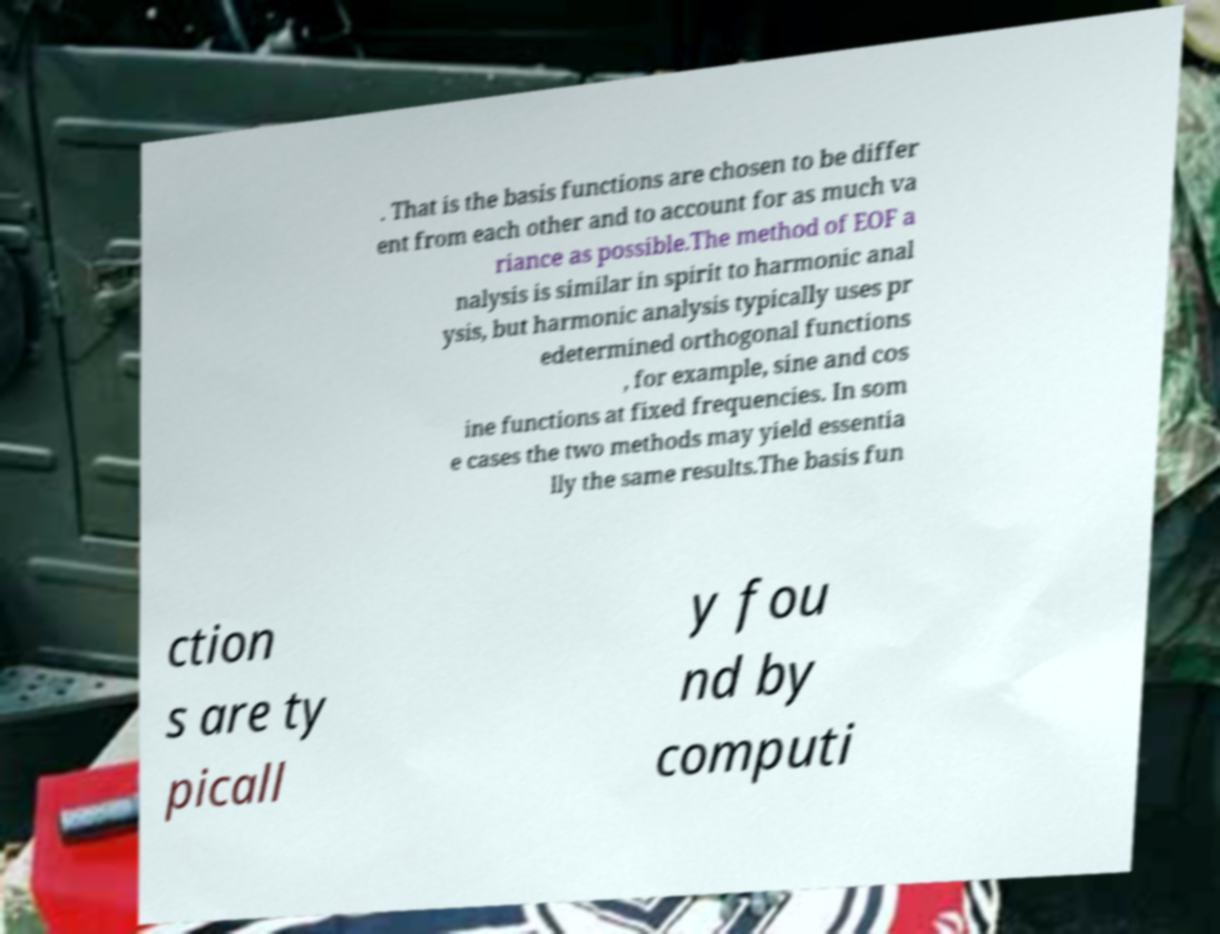Can you accurately transcribe the text from the provided image for me? . That is the basis functions are chosen to be differ ent from each other and to account for as much va riance as possible.The method of EOF a nalysis is similar in spirit to harmonic anal ysis, but harmonic analysis typically uses pr edetermined orthogonal functions , for example, sine and cos ine functions at fixed frequencies. In som e cases the two methods may yield essentia lly the same results.The basis fun ction s are ty picall y fou nd by computi 